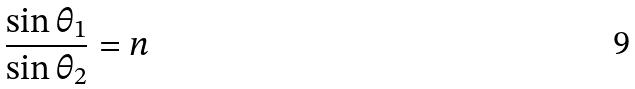Convert formula to latex. <formula><loc_0><loc_0><loc_500><loc_500>\frac { \sin \theta _ { 1 } } { \sin \theta _ { 2 } } = n</formula> 